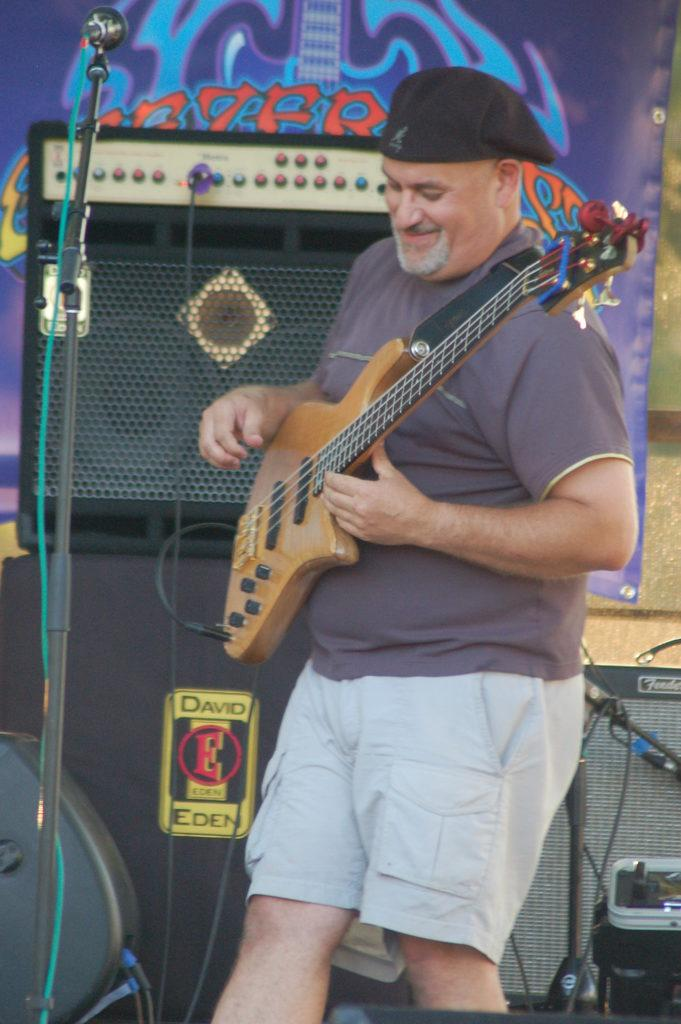Who is the main subject in the image? There is a man in the image. What is the man doing in the image? The man is playing a guitar. What object is present in the image that is commonly used for amplifying sound? There is a microphone in the image. What type of vessel is being used to transport trucks in the image? There is no vessel or trucks present in the image; it features a man playing a guitar and a microphone. 